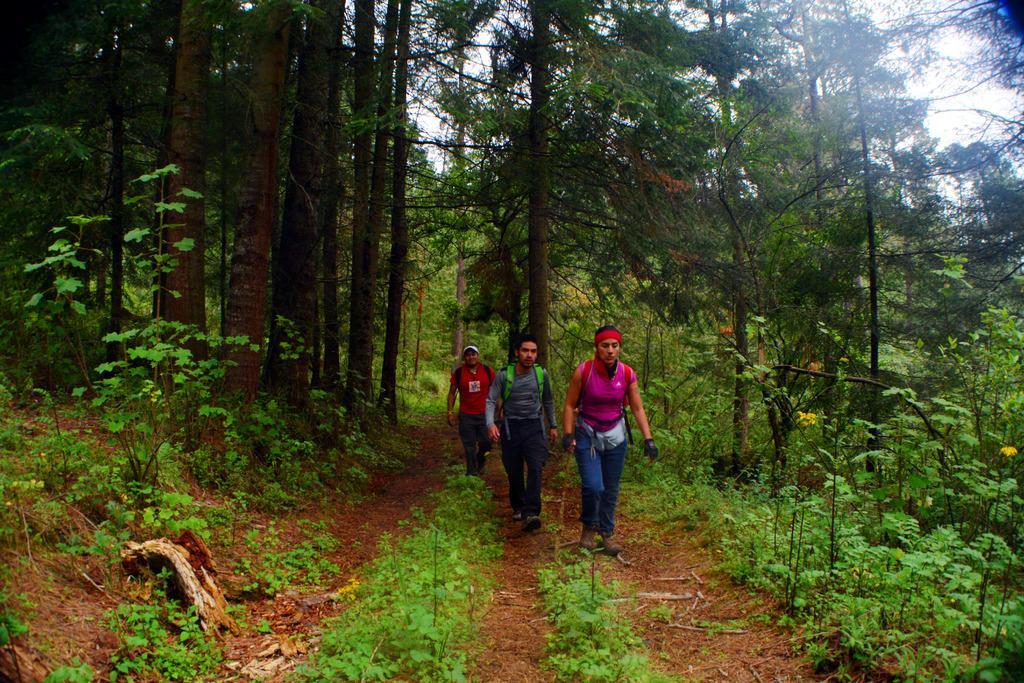In one or two sentences, can you explain what this image depicts? In the foreground of this picture, there are three men walking on the ground. In the background, we can see trees and the sky. 